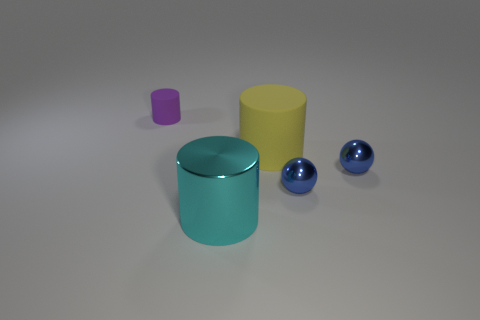Can you tell me the possible purpose of these objects? Based on their simple geometric shapes and the absence of any distinct features or markings that would indicate a specific function, these objects could be 3D models designed for graphical rendering tests or educational purposes to teach about colors, volumes, and spatial relationships. Do the objects indicate any particular style or design? The minimalist design and uniform matte finishes suggest a modern and perhaps utilitarian aesthetic. They could also represent a style that leans towards abstract or instructional design, where the focus is more on form and color than on intricate details or functionality. 